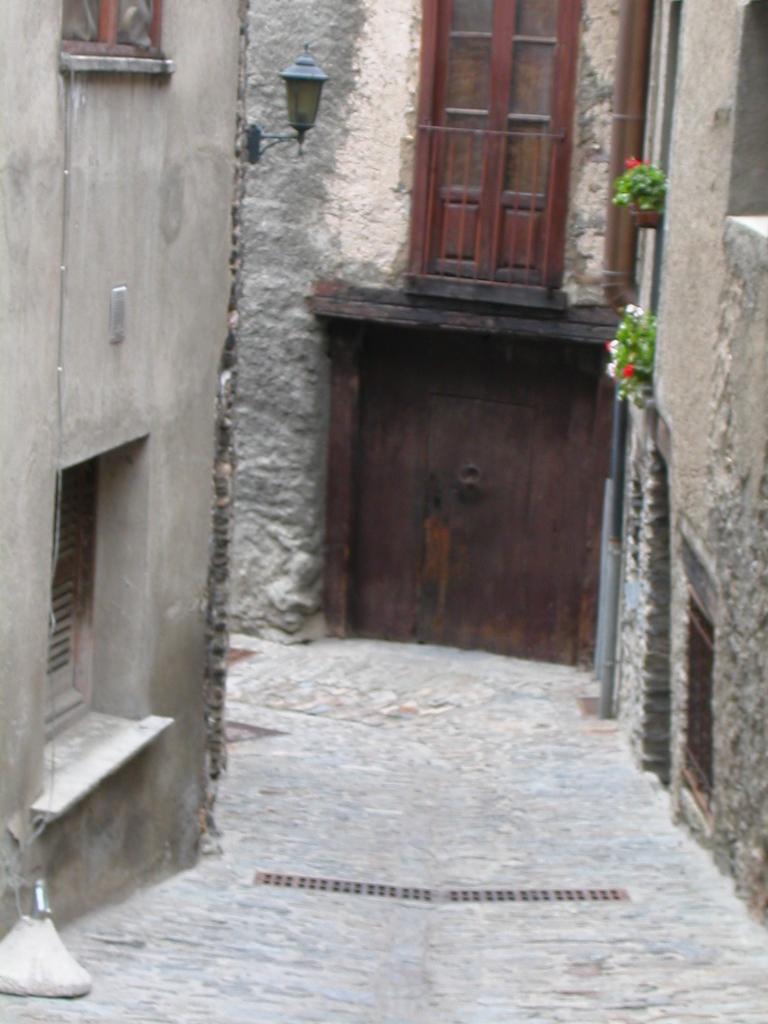How would you summarize this image in a sentence or two? In this image we can see a lane. To the both sides of the lane, buildings are there with wooden door, windows and light. 